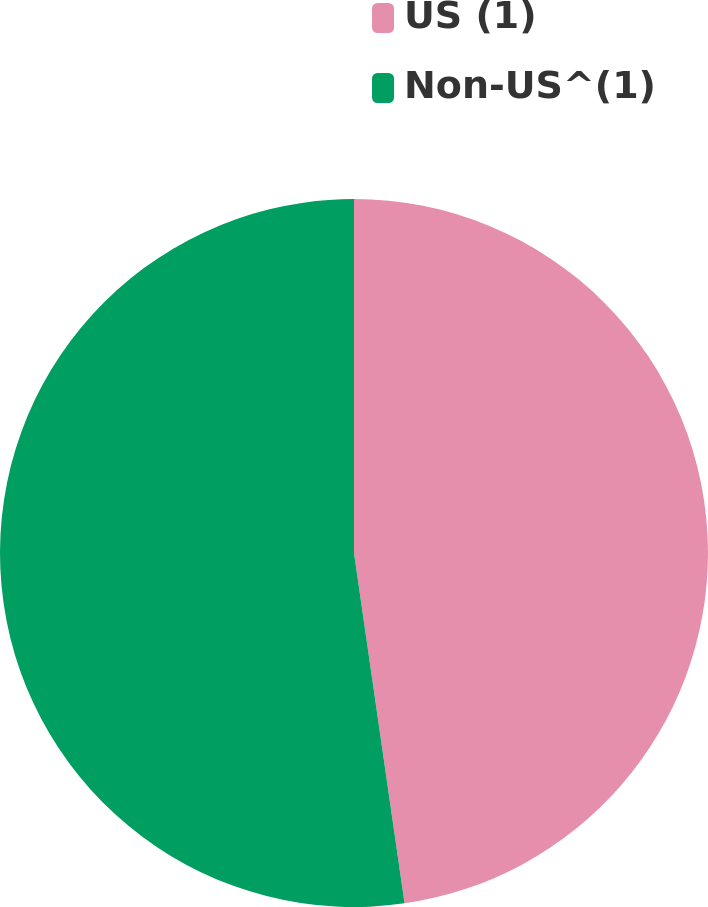Convert chart to OTSL. <chart><loc_0><loc_0><loc_500><loc_500><pie_chart><fcel>US (1)<fcel>Non-US^(1)<nl><fcel>47.72%<fcel>52.28%<nl></chart> 